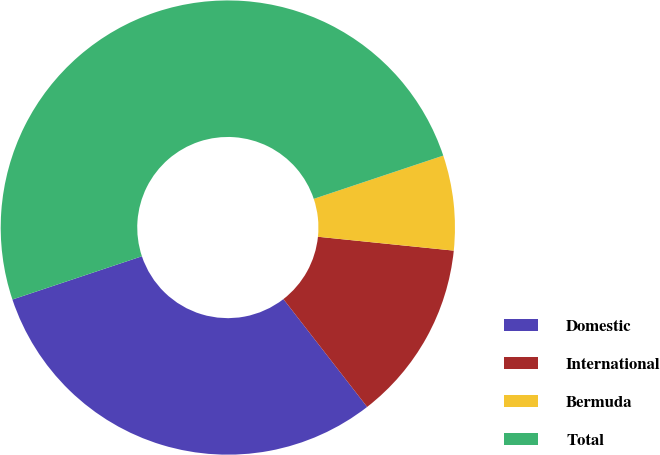Convert chart. <chart><loc_0><loc_0><loc_500><loc_500><pie_chart><fcel>Domestic<fcel>International<fcel>Bermuda<fcel>Total<nl><fcel>30.38%<fcel>12.87%<fcel>6.75%<fcel>50.0%<nl></chart> 